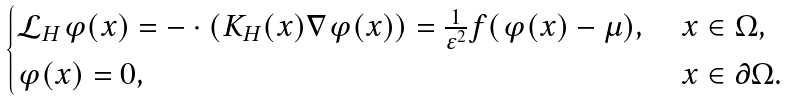<formula> <loc_0><loc_0><loc_500><loc_500>\begin{cases} \mathcal { L } _ { H } \varphi ( x ) = - \cdot ( K _ { H } ( x ) \nabla \varphi ( x ) ) = \frac { 1 } { \varepsilon ^ { 2 } } f ( \varphi ( x ) - \mu ) , \ & x \in \Omega , \\ \varphi ( x ) = 0 , \ & x \in \partial \Omega . \end{cases}</formula> 